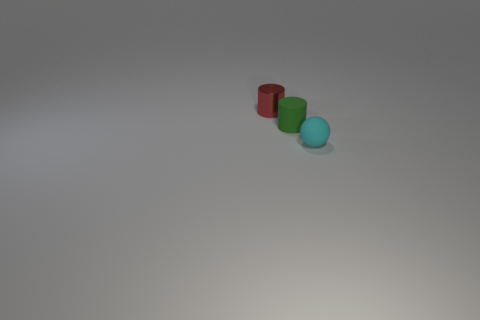Is there anything else that has the same shape as the small cyan matte object?
Make the answer very short. No. Are there any small green cylinders?
Keep it short and to the point. Yes. Are there an equal number of tiny red shiny cylinders behind the small red metal thing and shiny things?
Provide a succinct answer. No. Is there anything else that has the same material as the tiny sphere?
Offer a very short reply. Yes. What number of tiny objects are either cylinders or yellow things?
Keep it short and to the point. 2. Does the cylinder right of the tiny shiny cylinder have the same material as the red thing?
Offer a very short reply. No. What is the tiny cylinder that is to the right of the red shiny cylinder that is behind the rubber cylinder made of?
Your response must be concise. Rubber. How many green rubber objects have the same shape as the small red thing?
Your answer should be very brief. 1. There is a cyan matte object in front of the matte thing that is behind the small matte thing that is right of the small matte cylinder; how big is it?
Provide a short and direct response. Small. What number of blue things are cylinders or rubber things?
Your response must be concise. 0. 